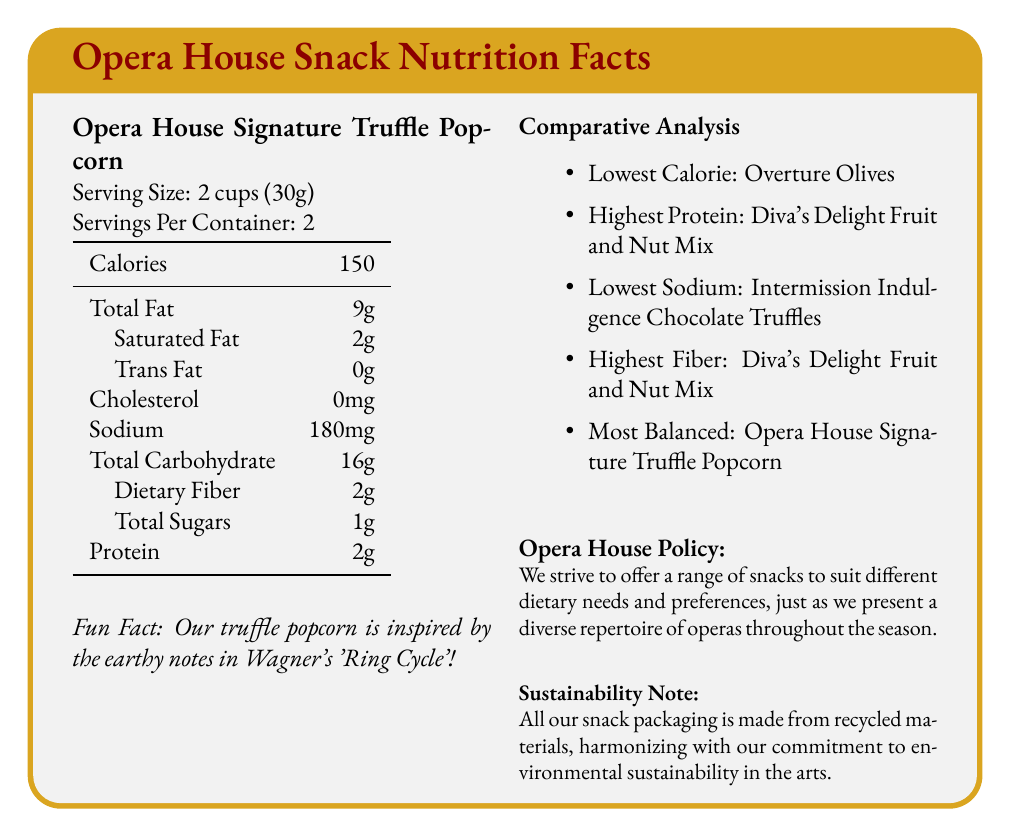who does the Opera House Signature Truffle Popcorn's fun fact relate to? The fun fact for the Opera House Signature Truffle Popcorn mentions it is inspired by the earthy notes in Wagner's 'Ring Cycle'.
Answer: Wagner's 'Ring Cycle' which snack has the highest protein content? The comparative analysis section indicates that the Diva's Delight Fruit and Nut Mix has the highest protein content.
Answer: Diva's Delight Fruit and Nut Mix what is the serving size for Intermission Indulgence Chocolate Truffles? The serving size for Intermission Indulgence Chocolate Truffles is noted as 3 pieces (42g).
Answer: 3 pieces (42g) how much sodium is in a serving of Maestro's Munchies Cheese Straws? The document shows that a serving of Maestro's Munchies Cheese Straws contains 220mg of sodium.
Answer: 220mg what snack is noted to be the most balanced? The comparative analysis section lists Opera House Signature Truffle Popcorn as the most balanced snack.
Answer: Opera House Signature Truffle Popcorn which snack has the fewest calories per serving? A. Diva's Delight Fruit and Nut Mix B. Overture Olives C. Intermission Indulgence Chocolate Truffles D. Maestro's Munchies Cheese Straws Overture Olives have the fewest calories per serving, with only 60 calories.
Answer: B which snack contains the highest amount of dietary fiber? A. Opera House Signature Truffle Popcorn B. Diva's Delight Fruit and Nut Mix C. Intermission Indulgence Chocolate Truffles D. Overture Olives The Diva's Delight Fruit and Nut Mix contains the highest amount of dietary fiber, with 3g per serving.
Answer: B is Intermission Indulgence Chocolate Truffles the snack with the most calcium? The snack with the most calcium is Maestro's Munchies Cheese Straws, which contains 100mg per serving, while Intermission Indulgence Chocolate Truffles contain only 40mg per serving.
Answer: No does the Opera House Signature Truffle Popcorn have any trans fat? The document specifies that the Opera House Signature Truffle Popcorn contains 0g of trans fat.
Answer: No summarize the main idea of the document The document provides detailed nutritional information for each snack, emphasizing different nutritional highlights and interesting facts, and underscores the Opera House's dedication to catering to different dietary preferences and environmental responsibility.
Answer: The document presents a comparative analysis of the nutritional facts for popular pre-performance snacks sold at the opera house, highlighting various aspects such as serving size, calorie content, fat content, protein, and fun facts about each snack. It also includes information about the Opera House's policy on offering diverse snacks to suit dietary needs and their commitment to sustainability. which snack is specifically noted for its environmental sustainability in the art section? The document mentions that all snack packaging is made from recycled materials as part of the Opera House's commitment to environmental sustainability, but it does not specify any particular snack for this attribute.
Answer: Cannot be determined why are the fun facts related to opera included in the document? The document mentions fun facts for each snack, but it does not explicitly explain why these fun facts are included.
Answer: Not enough information 